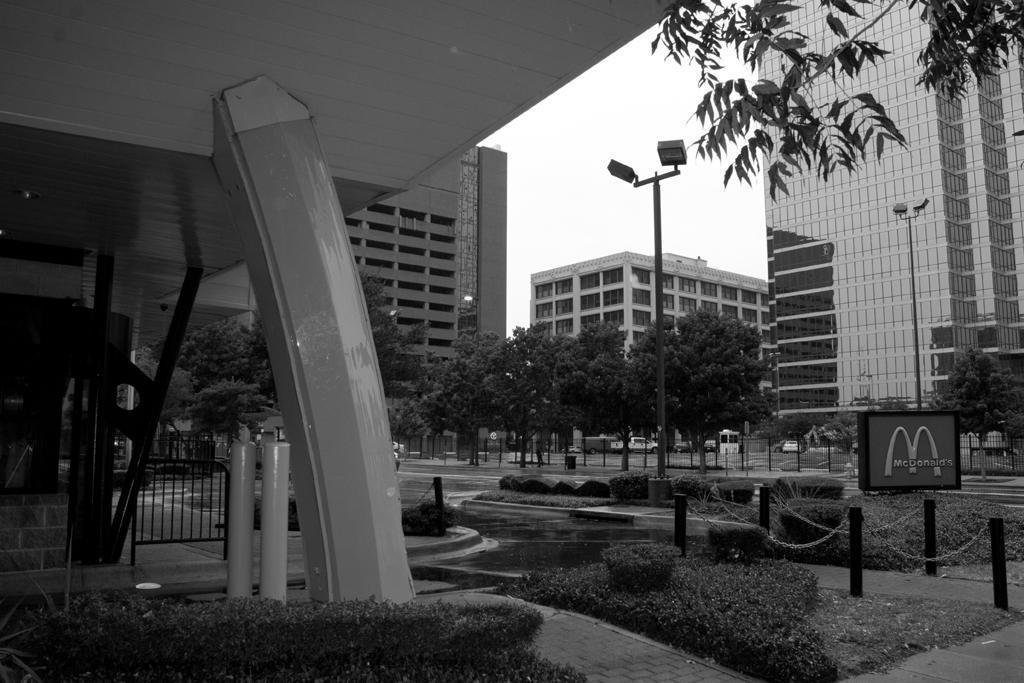How would you summarize this image in a sentence or two? In this image we can see trees, light pole, buildings, grass, plants, vehicles and sky. 